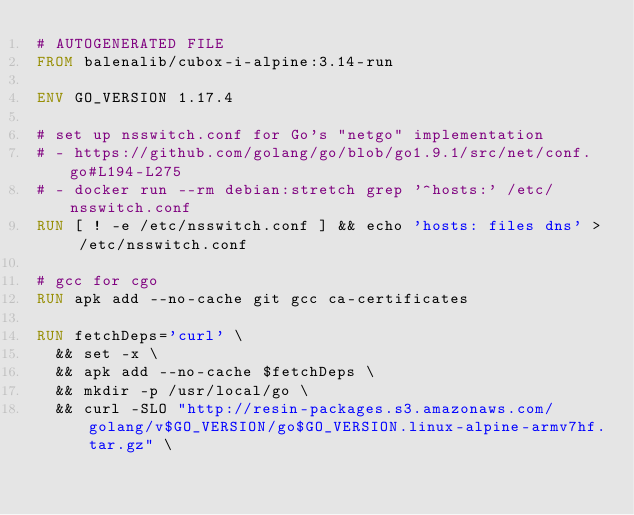<code> <loc_0><loc_0><loc_500><loc_500><_Dockerfile_># AUTOGENERATED FILE
FROM balenalib/cubox-i-alpine:3.14-run

ENV GO_VERSION 1.17.4

# set up nsswitch.conf for Go's "netgo" implementation
# - https://github.com/golang/go/blob/go1.9.1/src/net/conf.go#L194-L275
# - docker run --rm debian:stretch grep '^hosts:' /etc/nsswitch.conf
RUN [ ! -e /etc/nsswitch.conf ] && echo 'hosts: files dns' > /etc/nsswitch.conf

# gcc for cgo
RUN apk add --no-cache git gcc ca-certificates

RUN fetchDeps='curl' \
	&& set -x \
	&& apk add --no-cache $fetchDeps \
	&& mkdir -p /usr/local/go \
	&& curl -SLO "http://resin-packages.s3.amazonaws.com/golang/v$GO_VERSION/go$GO_VERSION.linux-alpine-armv7hf.tar.gz" \</code> 